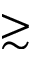<formula> <loc_0><loc_0><loc_500><loc_500>\gtrsim</formula> 